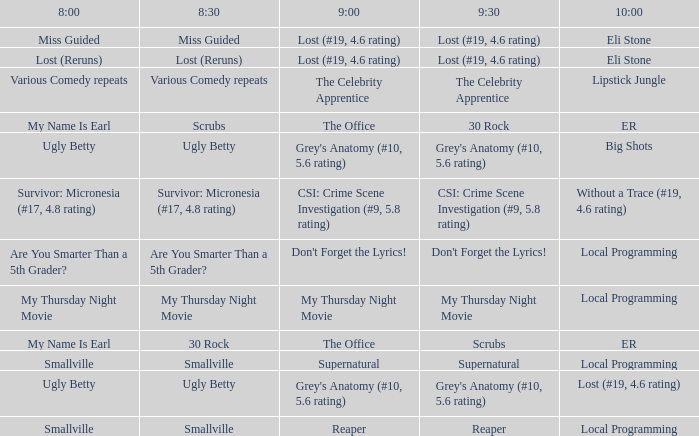What is at 9:00 when at 10:00 it is local programming and at 9:30 it is my thursday night movie? My Thursday Night Movie. 